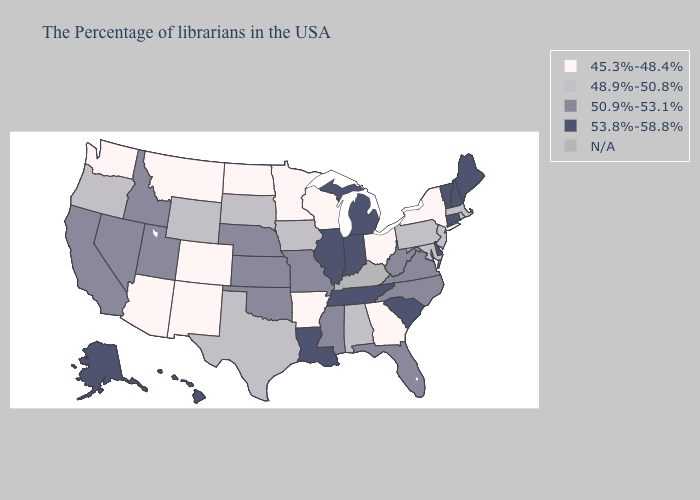Among the states that border Nevada , does Arizona have the lowest value?
Keep it brief. Yes. What is the lowest value in states that border New Hampshire?
Answer briefly. 48.9%-50.8%. Name the states that have a value in the range 53.8%-58.8%?
Concise answer only. Maine, New Hampshire, Vermont, Connecticut, Delaware, South Carolina, Michigan, Indiana, Tennessee, Illinois, Louisiana, Alaska, Hawaii. Does the map have missing data?
Short answer required. Yes. Does Alaska have the highest value in the USA?
Be succinct. Yes. What is the lowest value in the South?
Answer briefly. 45.3%-48.4%. What is the highest value in the South ?
Write a very short answer. 53.8%-58.8%. What is the value of New Jersey?
Give a very brief answer. 48.9%-50.8%. What is the value of Tennessee?
Be succinct. 53.8%-58.8%. Does Maine have the lowest value in the USA?
Quick response, please. No. Does Ohio have the highest value in the MidWest?
Be succinct. No. Does the first symbol in the legend represent the smallest category?
Keep it brief. Yes. Does Wyoming have the highest value in the West?
Quick response, please. No. 